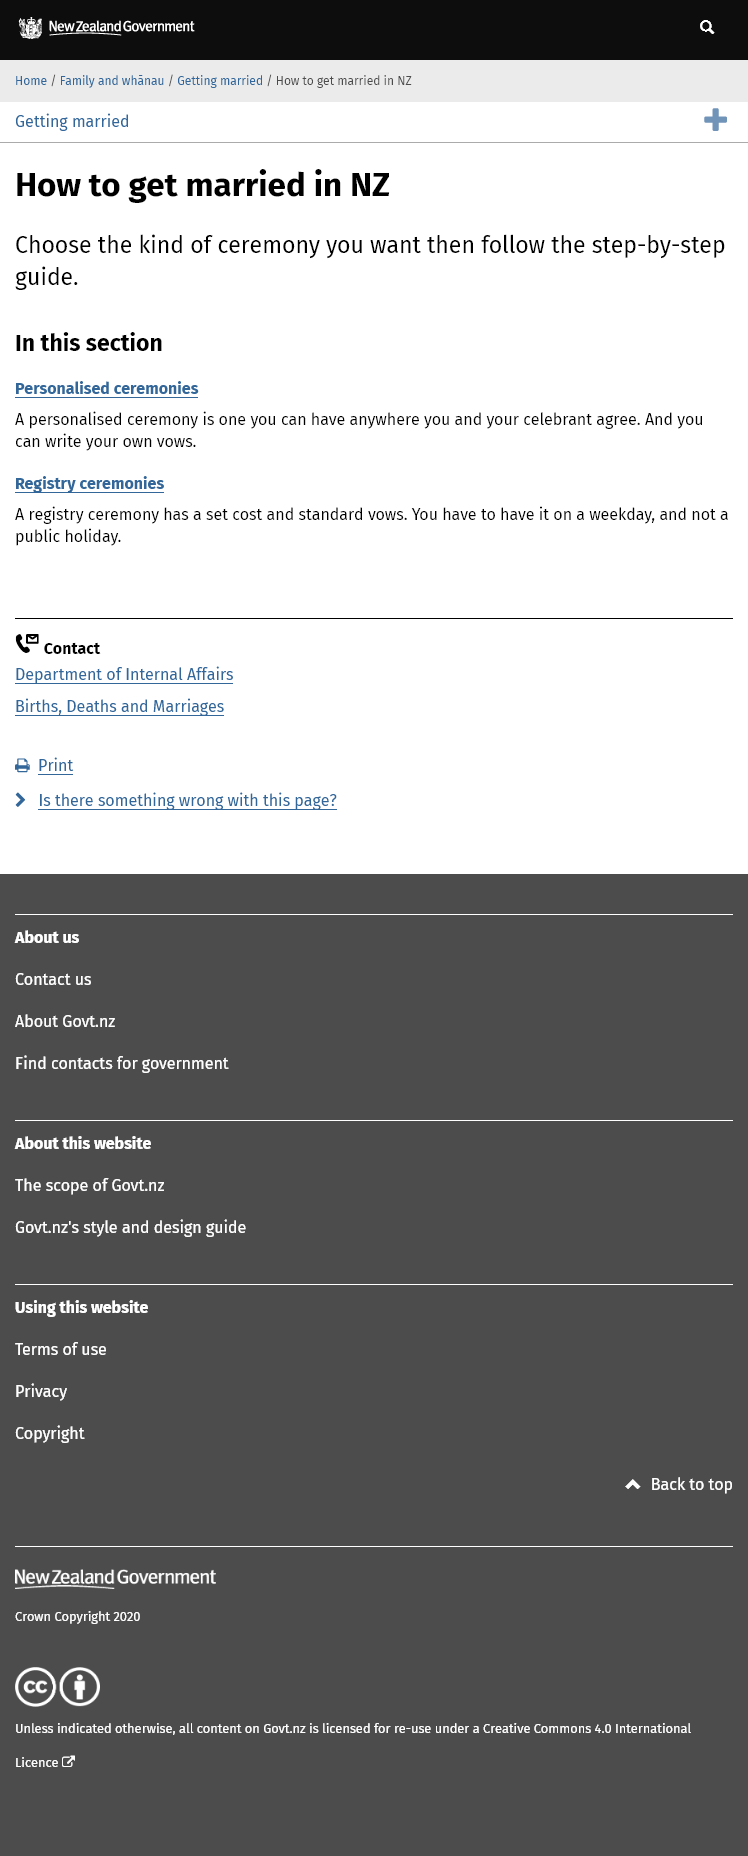Point out several critical features in this image. It is necessary for a registry ceremony to be held on a weekday. As mentioned in the article, personalized ceremonies and registry ceremonies are listed as two types of ceremonies. It is possible to write your own vows for a ceremony that is tailored to your personal preferences, as opposed to following a traditional script. 